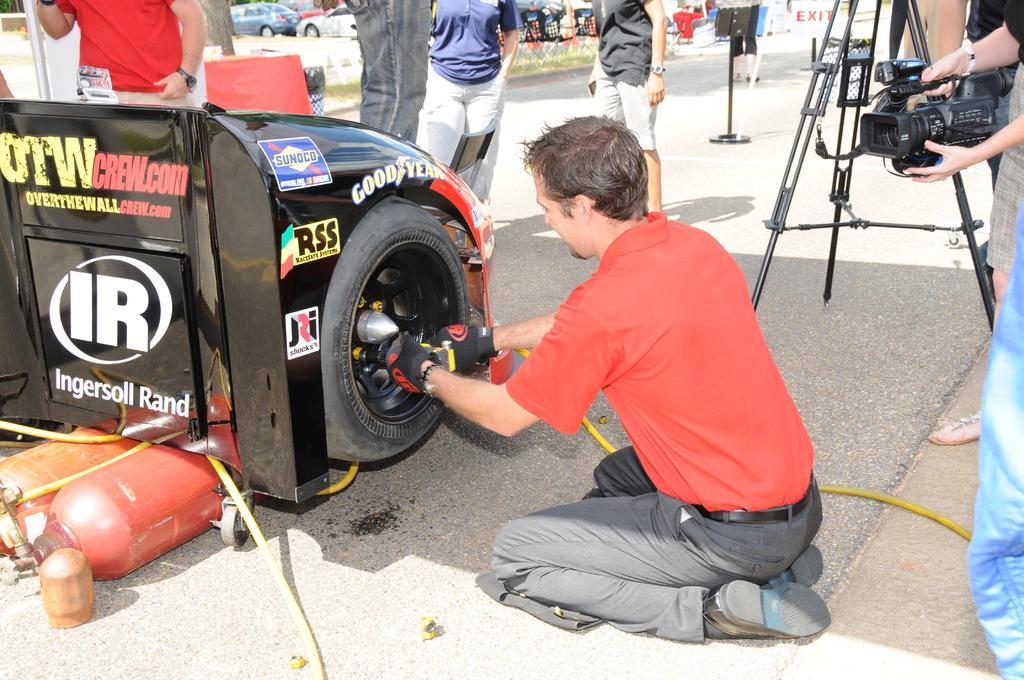Please provide a concise description of this image. In the picture we can see a part of the car with a wheel and the car is black in color and to it we can see some advertisement symbols on it and a man sitting on knees and repairing to the wheels, be is with gloves and red T-shirt and behind it we can see a person standing on the path and holding a camera and behind him we can see a tripod and in the background we can see some people are standing and behind them we can see some cars are parked. 